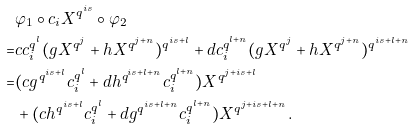<formula> <loc_0><loc_0><loc_500><loc_500>& \varphi _ { 1 } \circ c _ { i } X ^ { q ^ { i s } } \circ \varphi _ { 2 } \\ = & c c _ { i } ^ { q ^ { l } } ( g X ^ { q ^ { j } } + h X ^ { q ^ { j + n } } ) ^ { q ^ { i s + l } } + d c _ { i } ^ { q ^ { l + n } } ( g X ^ { q ^ { j } } + h X ^ { q ^ { j + n } } ) ^ { q ^ { i s + l + n } } \\ = & ( c g ^ { q ^ { i s + l } } c _ { i } ^ { q ^ { l } } + d h ^ { q ^ { i s + l + n } } c _ { i } ^ { q ^ { l + n } } ) X ^ { q ^ { j + i s + l } } \\ & + ( c h ^ { q ^ { i s + l } } c _ { i } ^ { q ^ { l } } + d g ^ { q ^ { i s + l + n } } c _ { i } ^ { q ^ { l + n } } ) X ^ { q ^ { j + i s + l + n } } .</formula> 